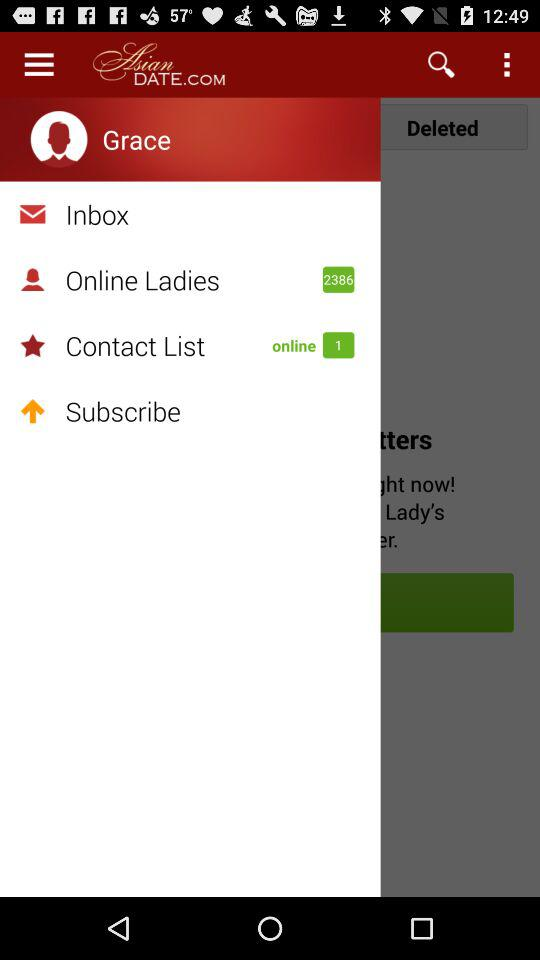How many "Online Ladies" are there? There are 2386 "Online Ladies". 